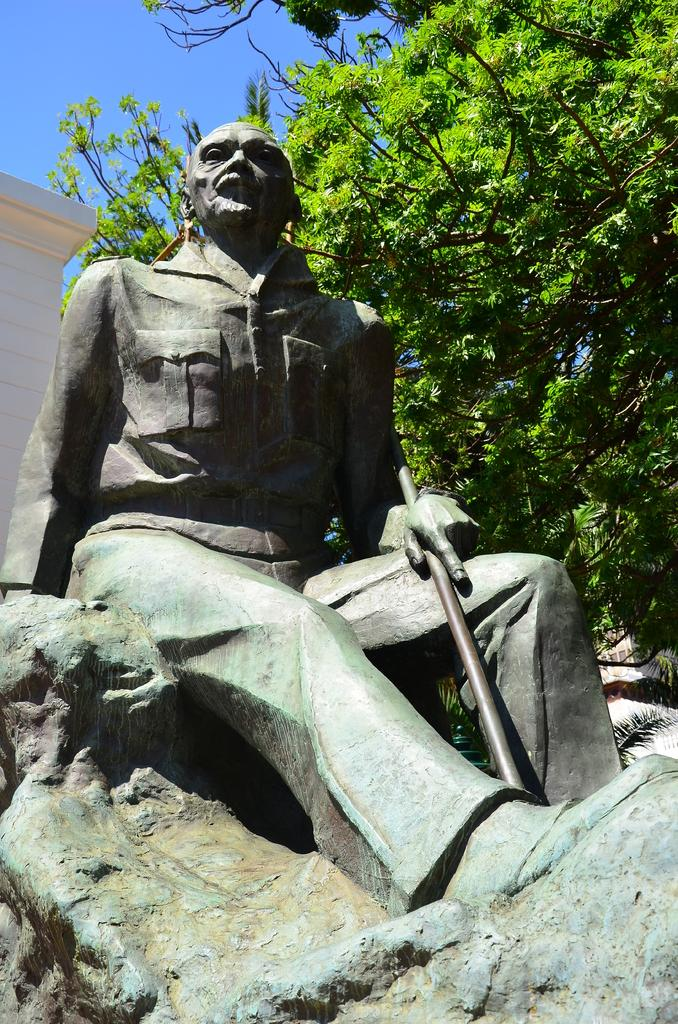What is the main subject in the center of the image? There is a statue in the center of the image. What can be seen in the background of the image? There is a building and a tree in the background of the image. What is visible in the sky in the image? The sky is visible in the background of the image. How many times does the statue twist in the image? The statue does not twist in the image; it is a stationary object. 